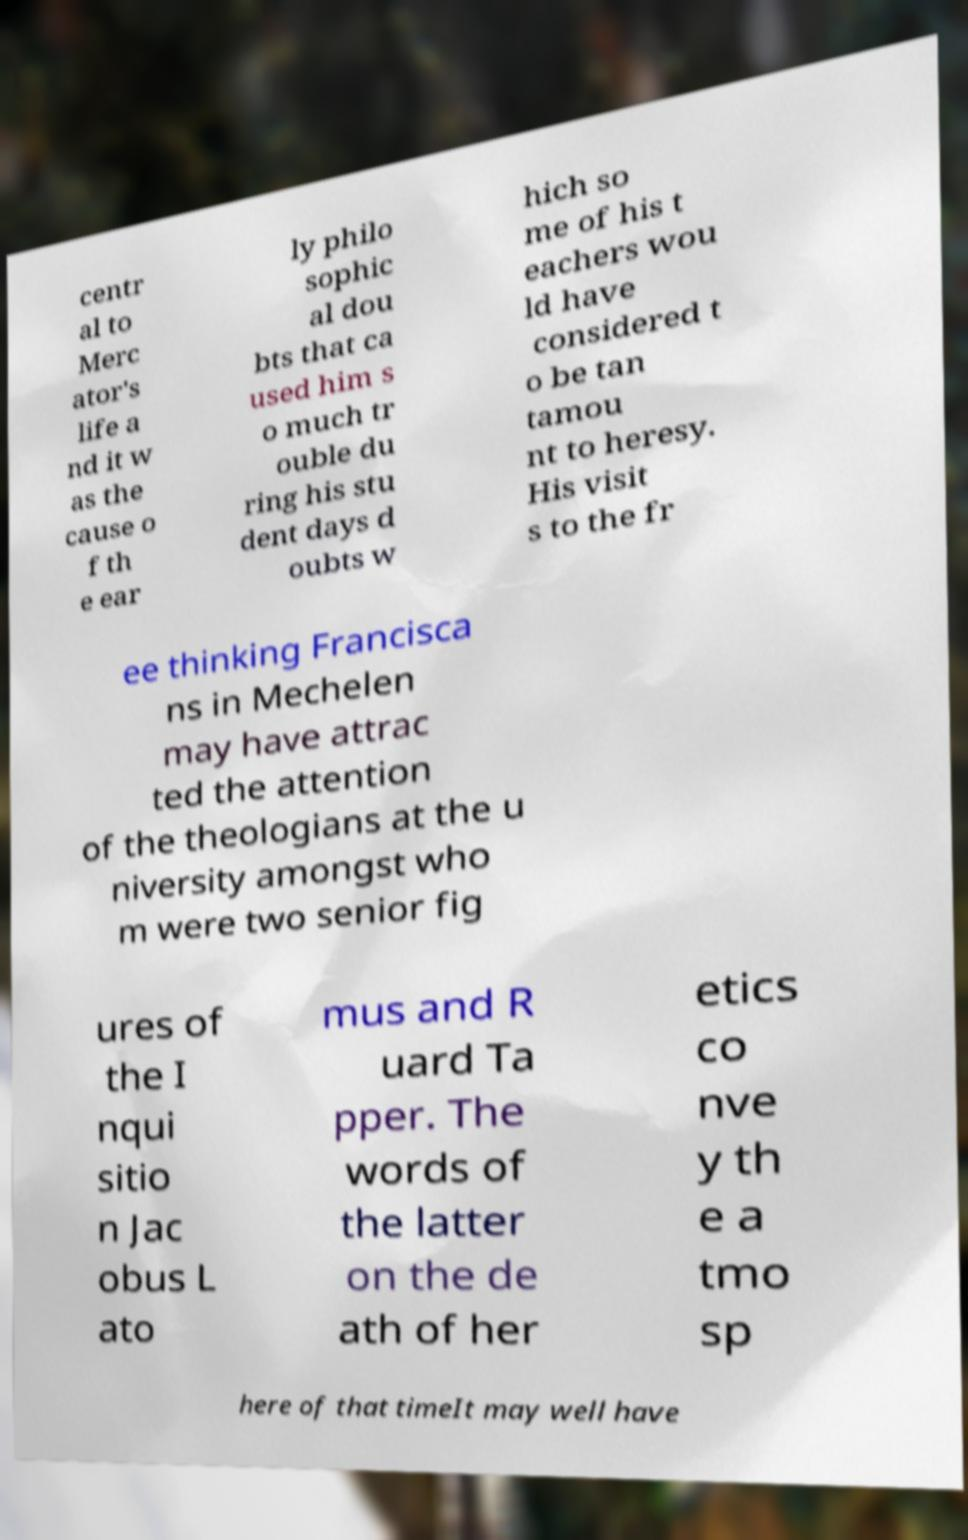For documentation purposes, I need the text within this image transcribed. Could you provide that? centr al to Merc ator's life a nd it w as the cause o f th e ear ly philo sophic al dou bts that ca used him s o much tr ouble du ring his stu dent days d oubts w hich so me of his t eachers wou ld have considered t o be tan tamou nt to heresy. His visit s to the fr ee thinking Francisca ns in Mechelen may have attrac ted the attention of the theologians at the u niversity amongst who m were two senior fig ures of the I nqui sitio n Jac obus L ato mus and R uard Ta pper. The words of the latter on the de ath of her etics co nve y th e a tmo sp here of that timeIt may well have 